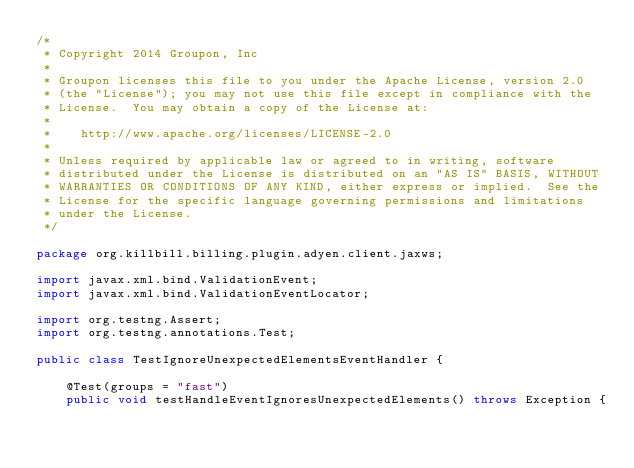<code> <loc_0><loc_0><loc_500><loc_500><_Java_>/*
 * Copyright 2014 Groupon, Inc
 *
 * Groupon licenses this file to you under the Apache License, version 2.0
 * (the "License"); you may not use this file except in compliance with the
 * License.  You may obtain a copy of the License at:
 *
 *    http://www.apache.org/licenses/LICENSE-2.0
 *
 * Unless required by applicable law or agreed to in writing, software
 * distributed under the License is distributed on an "AS IS" BASIS, WITHOUT
 * WARRANTIES OR CONDITIONS OF ANY KIND, either express or implied.  See the
 * License for the specific language governing permissions and limitations
 * under the License.
 */

package org.killbill.billing.plugin.adyen.client.jaxws;

import javax.xml.bind.ValidationEvent;
import javax.xml.bind.ValidationEventLocator;

import org.testng.Assert;
import org.testng.annotations.Test;

public class TestIgnoreUnexpectedElementsEventHandler {

    @Test(groups = "fast")
    public void testHandleEventIgnoresUnexpectedElements() throws Exception {</code> 